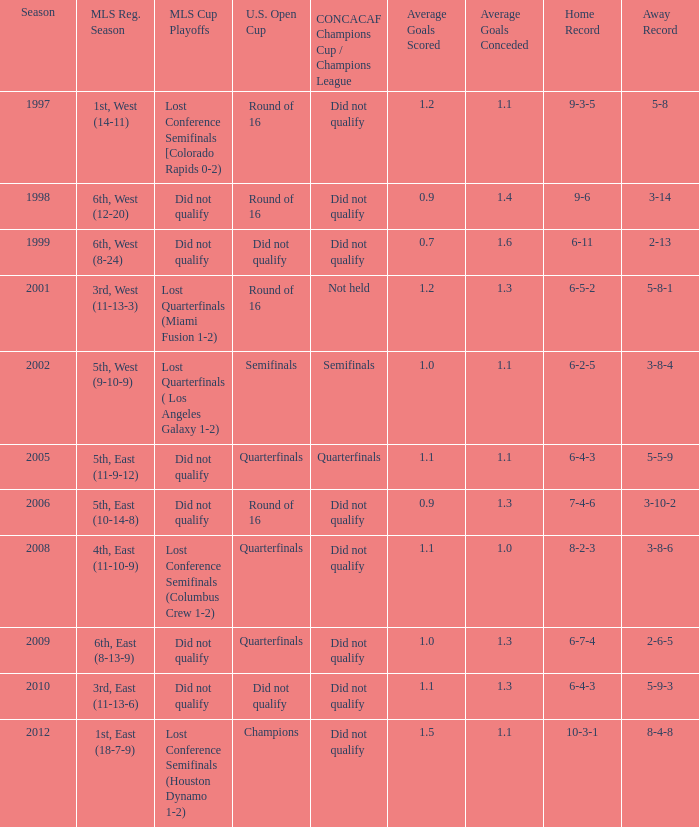What were the team's positions in the regular season when they advanced to the quarterfinals in the u.s. open cup but failed to qualify for the concaf champions cup? 4th, East (11-10-9), 6th, East (8-13-9). 